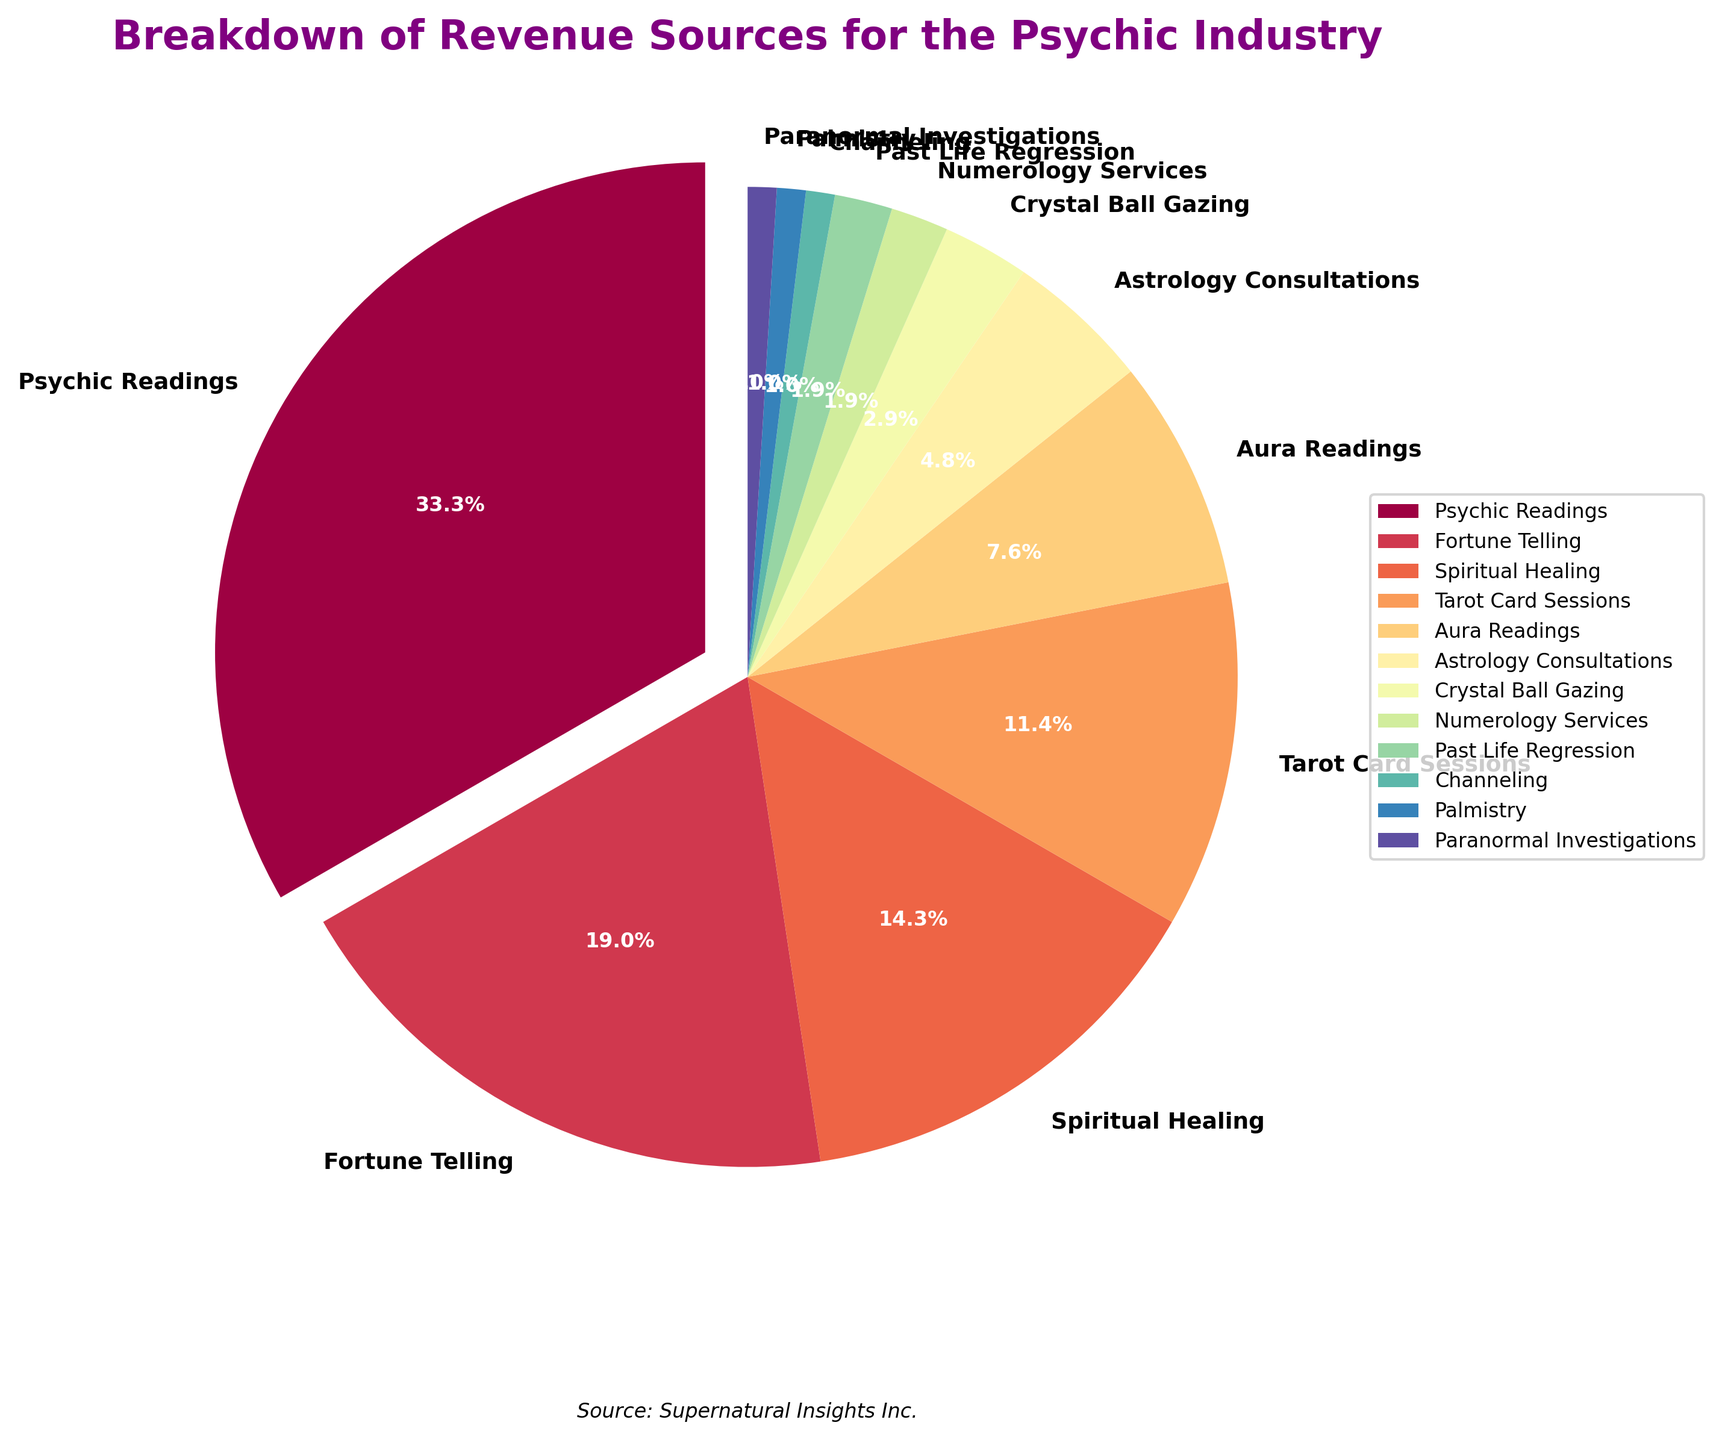Which category contributes the most to the revenue in the psychic industry? The figure shows that the largest section of the pie chart, which is also exploded, represents Psychic Readings. This section has the highest percentage of 35%.
Answer: Psychic Readings Which two categories together make up over 50% of the revenue? By examining the percentages in the pie chart, Psychic Readings at 35% and Fortune Telling at 20% together sum up to 55%, which is over 50%.
Answer: Psychic Readings and Fortune Telling What is the difference in revenue percentage between Spiritual Healing and Tarot Card Sessions? According to the pie chart, Spiritual Healing stands at 15% and Tarot Card Sessions at 12%. The difference between these two percentages is 15% - 12% = 3%.
Answer: 3% Which category holds the smallest revenue share, and what is its percentage? By looking at the smallest section of the pie chart, Channeling, Palmistry, and Paranormal Investigations each have the smallest slice with 1%.
Answer: Channeling, Palmistry, and Paranormal Investigations, each at 1% Combine the revenue percentages of Aura Readings, Astrology Consultations, and Crystal Ball Gazing. What is the total? According to the pie chart, Aura Readings is 8%, Astrology Consultations is 5%, and Crystal Ball Gazing is 3%. Summing them up, 8% + 5% + 3% = 16%.
Answer: 16% How does the percentage of Numerology Services compare to Past Life Regression? The pie chart shows that both Numerology Services and Past Life Regression have the same percentage of 2%.
Answer: They are equal What percentage of the revenue is accounted for by categories contributing 5% or less each? Identifying the categories contributing 5% or less: Astrology Consultations (5%), Crystal Ball Gazing (3%), Numerology Services (2%), Past Life Regression (2%), Channeling (1%), Palmistry (1%), and Paranormal Investigations (1%). Summing these up: 5% + 3% + 2% + 2% + 1% + 1% + 1% = 15%.
Answer: 15% Compare Aura Readings and Crystal Ball Gazing in terms of their revenue share. By how much do they differ? The pie chart indicates Aura Readings hold an 8% share, while Crystal Ball Gazing holds a 3% share. The difference between them is 8% - 3% = 5%.
Answer: 5% What is the average revenue percentage of Palmistry, Channeling, and Paranormal Investigations? Each of these categories has a 1% share. Adding them gives us 1% + 1% + 1% = 3%. To find the average, divide by the number of categories, 3% / 3 = 1%.
Answer: 1% If we combine the revenues of Fortune Telling and Tarot Card Sessions, do they exceed the revenue from Psychic Readings? Fortune Telling has a 20% share, and Tarot Card Sessions have 12%. Together they sum up to 20% + 12% = 32%, which is less than the 35% share of Psychic Readings.
Answer: No 